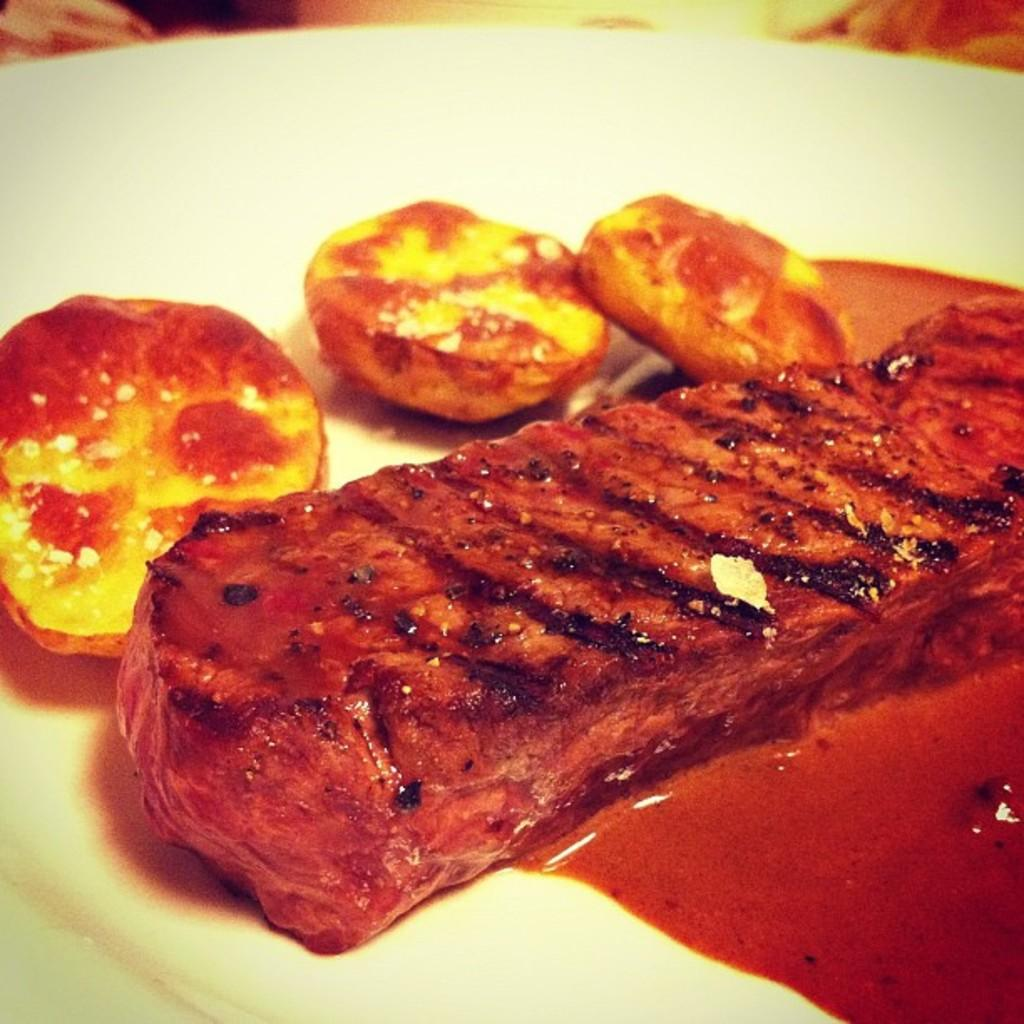What is present on the plate in the image? There is food on the plate in the image. Where are the dolls playing in the bedroom in the image? There are no dolls or bedroom present in the image; it only features a plate of food. 